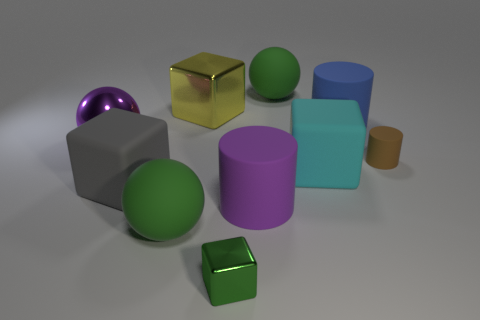Subtract all brown cubes. Subtract all red balls. How many cubes are left? 4 Subtract all cylinders. How many objects are left? 7 Add 6 matte cubes. How many matte cubes are left? 8 Add 5 large yellow metallic objects. How many large yellow metallic objects exist? 6 Subtract 0 cyan cylinders. How many objects are left? 10 Subtract all blue rubber things. Subtract all purple things. How many objects are left? 7 